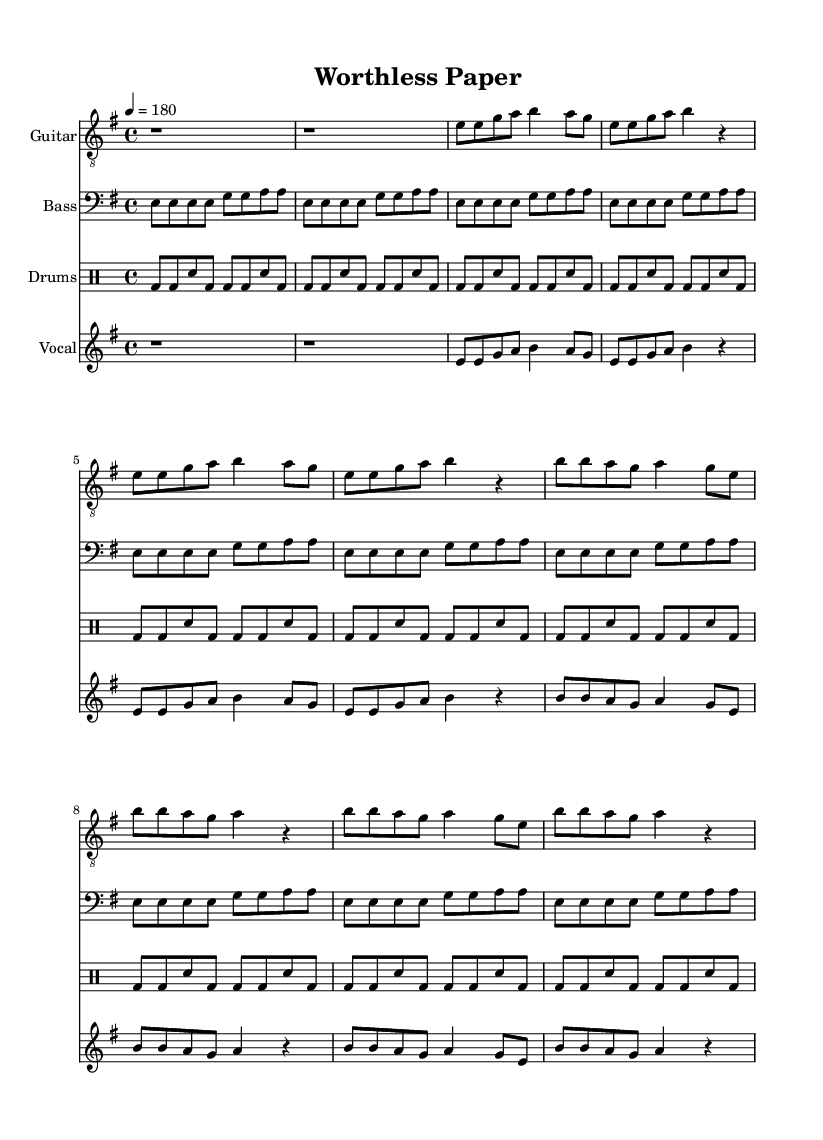What is the key signature of this music? The key signature is E minor, indicated by the presence of one sharp (F sharp). This is determined by analyzing the global settings in the sheet music.
Answer: E minor What is the time signature of this music? The time signature is 4/4, which means there are four beats in each measure and a quarter note receives one beat. This is explicitly noted in the global section of the code.
Answer: 4/4 What is the tempo marking for this piece? The tempo is marked as 180 beats per minute, which indicates a fast pace for the piece. This information is derived from the tempo setting in the global section.
Answer: 180 How many measures are there in the verse section? There are a total of 8 measures in the verse section as identified by reviewing the music notation for the verses and counting the measures present.
Answer: 8 What instrument plays the main melody in this piece? The electric guitar plays the main melody as indicated by the melody line written for this instrument in the score. This is confirmed by the notation assigned to the electric guitar part.
Answer: Electric guitar What is the central theme conveyed in the chorus lyrics? The central theme of the chorus emphasizes the critique of paper currency being worthless and its negative effects on the poor, highlighting social injustice. This is inferred from the lyrics in the chorus section.
Answer: Worthless paper How does the drum pattern contribute to the overall punk feel of the music? The drum pattern is straightforward and repetitive, featuring bass drum and snare rhythms that create a driving energy typical of punk music, reinforcing the song's energetic and aggressive nature. This can be observed in the drumming section throughout the score.
Answer: Driving energy 